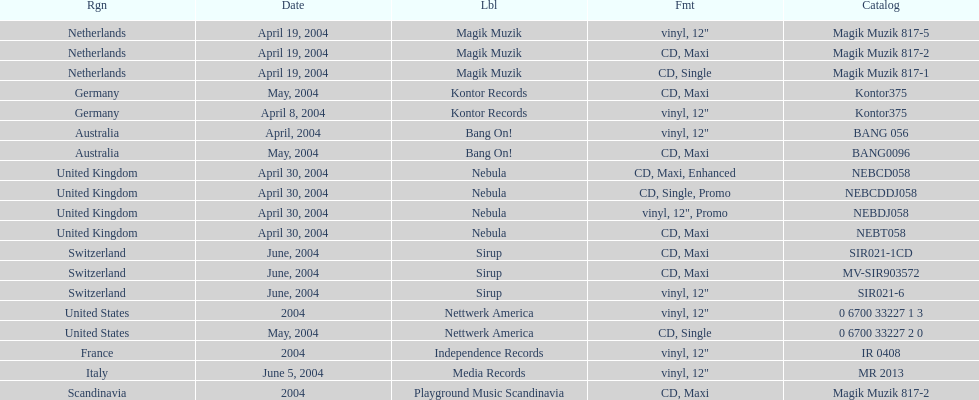What label was italy on? Media Records. 